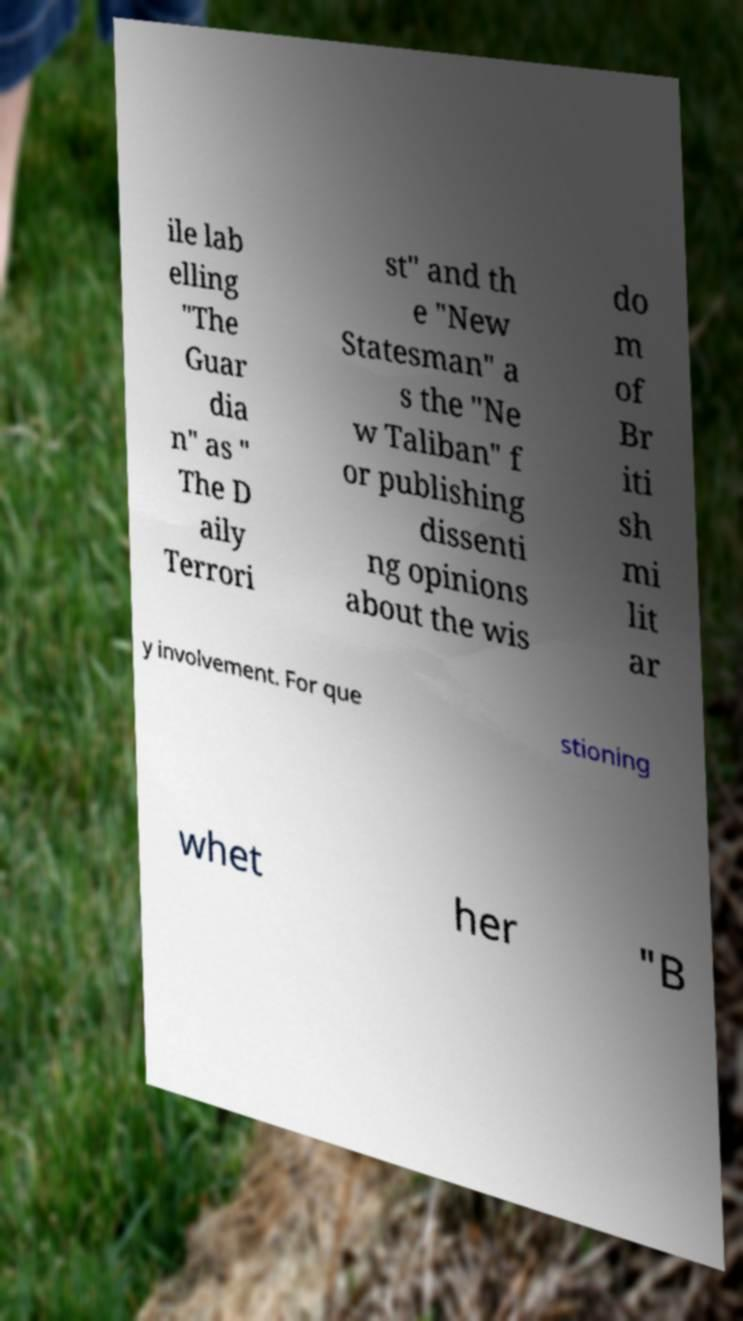Could you extract and type out the text from this image? ile lab elling "The Guar dia n" as " The D aily Terrori st" and th e "New Statesman" a s the "Ne w Taliban" f or publishing dissenti ng opinions about the wis do m of Br iti sh mi lit ar y involvement. For que stioning whet her "B 